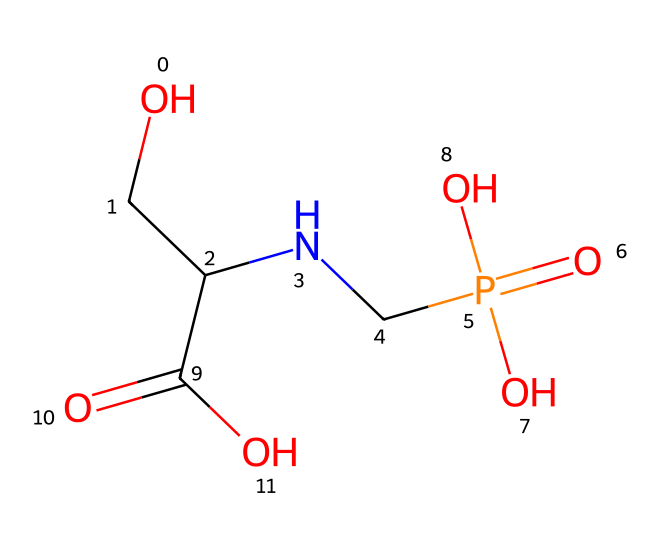What is the name of this chemical? The SMILES representation corresponds to the structural formula of glyphosate, which is a widely known herbicide.
Answer: glyphosate How many phosphorus atoms are in the molecule? By analyzing the SMILES, there's one instance of 'P', indicating one phosphorus atom in the structure.
Answer: 1 How many oxygen atoms are present in glyphosate? The SMILES contains four 'O' characters, representing four oxygen atoms found within the molecular structure.
Answer: 4 What functional group is attached to the phosphorus atom? The phosphorus atom is attached to a phosphate group indicated by ‘P(=O)(O)O’, showcasing a phosphoryl functional group.
Answer: phosphate Is glyphosate an amino acid derivative? The presence of the ‘N’ in the SMILES indicates an amine is part of the structure, confirming it's an amino acid derivative combined with a phosphorus compound.
Answer: yes What type of reaction could glyphosate inhibit due to its structure? Glyphosate acts as an herbicide by inhibiting the shikimic acid pathway, which is necessary for plant growth, indicating that it disrupts metabolic processes.
Answer: shikimic acid pathway What kind of bond connects phosphorus to oxygen in glyphosate? The phosphorus in glyphosate is primarily involved in covalent bonding with the oxygen atoms, which is common in phosphoryl groups.
Answer: covalent 